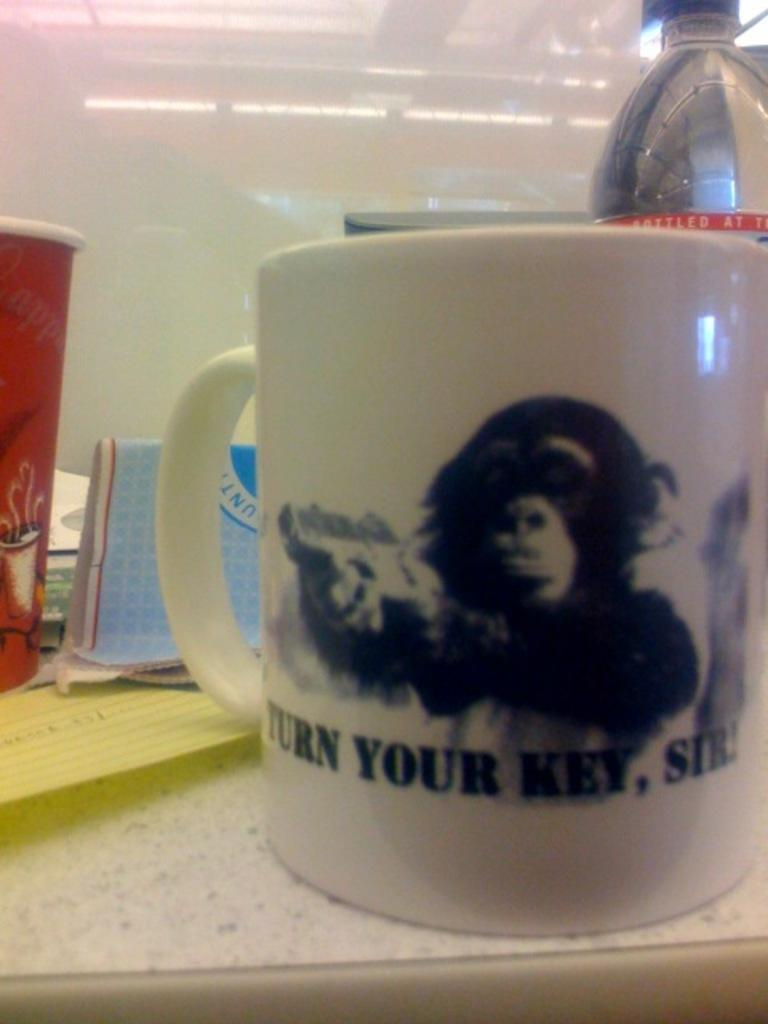<image>
Summarize the visual content of the image. a coffee mug with a monkey that says 'turn your key, sir!' 